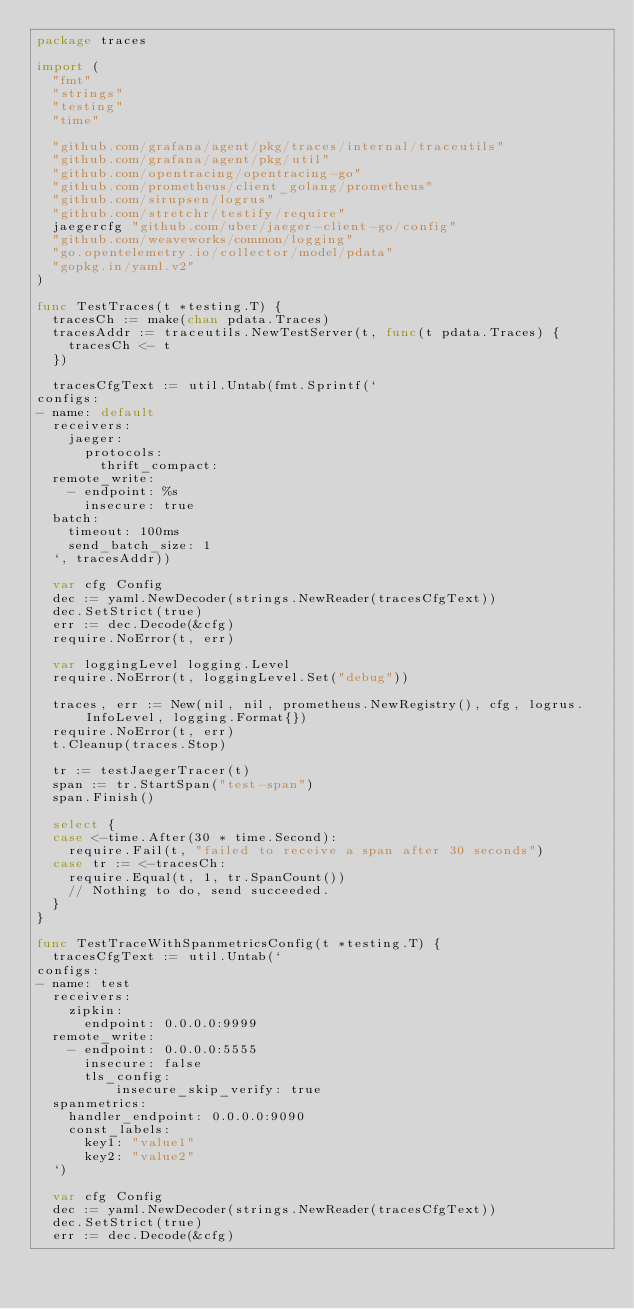<code> <loc_0><loc_0><loc_500><loc_500><_Go_>package traces

import (
	"fmt"
	"strings"
	"testing"
	"time"

	"github.com/grafana/agent/pkg/traces/internal/traceutils"
	"github.com/grafana/agent/pkg/util"
	"github.com/opentracing/opentracing-go"
	"github.com/prometheus/client_golang/prometheus"
	"github.com/sirupsen/logrus"
	"github.com/stretchr/testify/require"
	jaegercfg "github.com/uber/jaeger-client-go/config"
	"github.com/weaveworks/common/logging"
	"go.opentelemetry.io/collector/model/pdata"
	"gopkg.in/yaml.v2"
)

func TestTraces(t *testing.T) {
	tracesCh := make(chan pdata.Traces)
	tracesAddr := traceutils.NewTestServer(t, func(t pdata.Traces) {
		tracesCh <- t
	})

	tracesCfgText := util.Untab(fmt.Sprintf(`
configs:
- name: default
  receivers:
    jaeger:
      protocols:
        thrift_compact:
  remote_write:
  	- endpoint: %s
      insecure: true
  batch:
    timeout: 100ms
    send_batch_size: 1
	`, tracesAddr))

	var cfg Config
	dec := yaml.NewDecoder(strings.NewReader(tracesCfgText))
	dec.SetStrict(true)
	err := dec.Decode(&cfg)
	require.NoError(t, err)

	var loggingLevel logging.Level
	require.NoError(t, loggingLevel.Set("debug"))

	traces, err := New(nil, nil, prometheus.NewRegistry(), cfg, logrus.InfoLevel, logging.Format{})
	require.NoError(t, err)
	t.Cleanup(traces.Stop)

	tr := testJaegerTracer(t)
	span := tr.StartSpan("test-span")
	span.Finish()

	select {
	case <-time.After(30 * time.Second):
		require.Fail(t, "failed to receive a span after 30 seconds")
	case tr := <-tracesCh:
		require.Equal(t, 1, tr.SpanCount())
		// Nothing to do, send succeeded.
	}
}

func TestTraceWithSpanmetricsConfig(t *testing.T) {
	tracesCfgText := util.Untab(`
configs:
- name: test
  receivers:
    zipkin:
      endpoint: 0.0.0.0:9999
  remote_write:
    - endpoint: 0.0.0.0:5555
      insecure: false
      tls_config:
          insecure_skip_verify: true
  spanmetrics:
    handler_endpoint: 0.0.0.0:9090
    const_labels:
      key1: "value1"
      key2: "value2"
	`)

	var cfg Config
	dec := yaml.NewDecoder(strings.NewReader(tracesCfgText))
	dec.SetStrict(true)
	err := dec.Decode(&cfg)</code> 